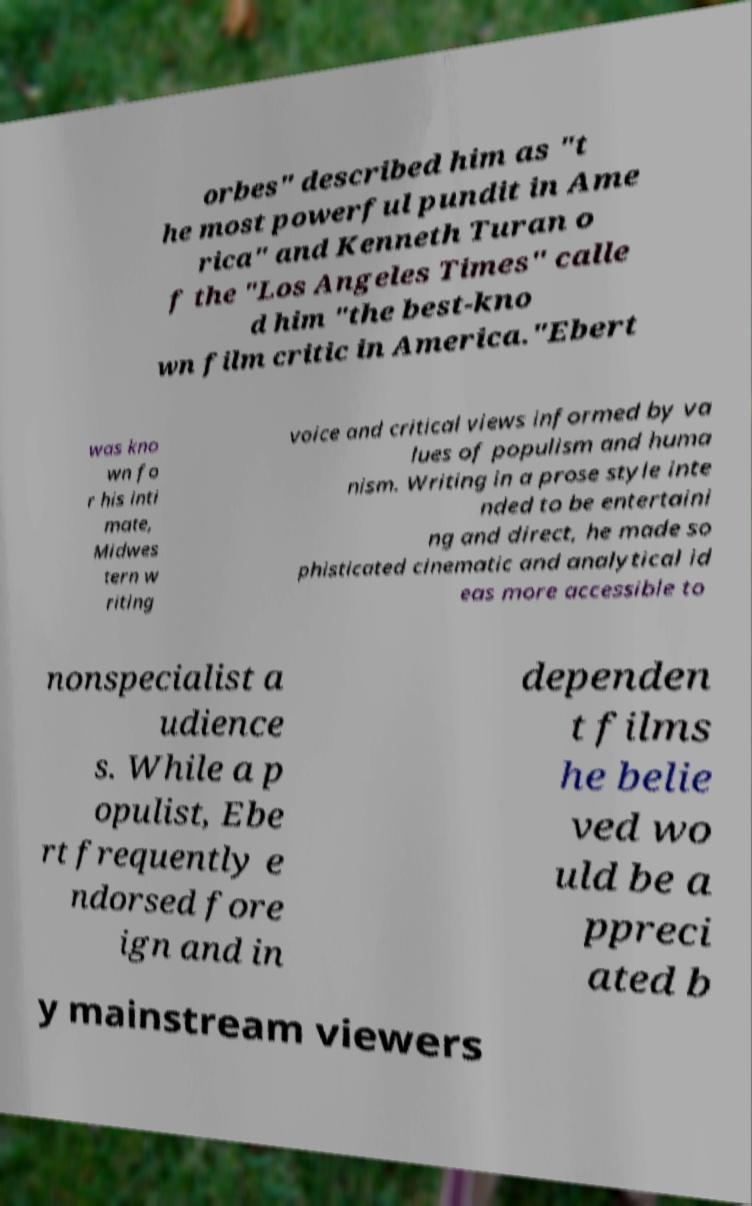For documentation purposes, I need the text within this image transcribed. Could you provide that? orbes" described him as "t he most powerful pundit in Ame rica" and Kenneth Turan o f the "Los Angeles Times" calle d him "the best-kno wn film critic in America."Ebert was kno wn fo r his inti mate, Midwes tern w riting voice and critical views informed by va lues of populism and huma nism. Writing in a prose style inte nded to be entertaini ng and direct, he made so phisticated cinematic and analytical id eas more accessible to nonspecialist a udience s. While a p opulist, Ebe rt frequently e ndorsed fore ign and in dependen t films he belie ved wo uld be a ppreci ated b y mainstream viewers 